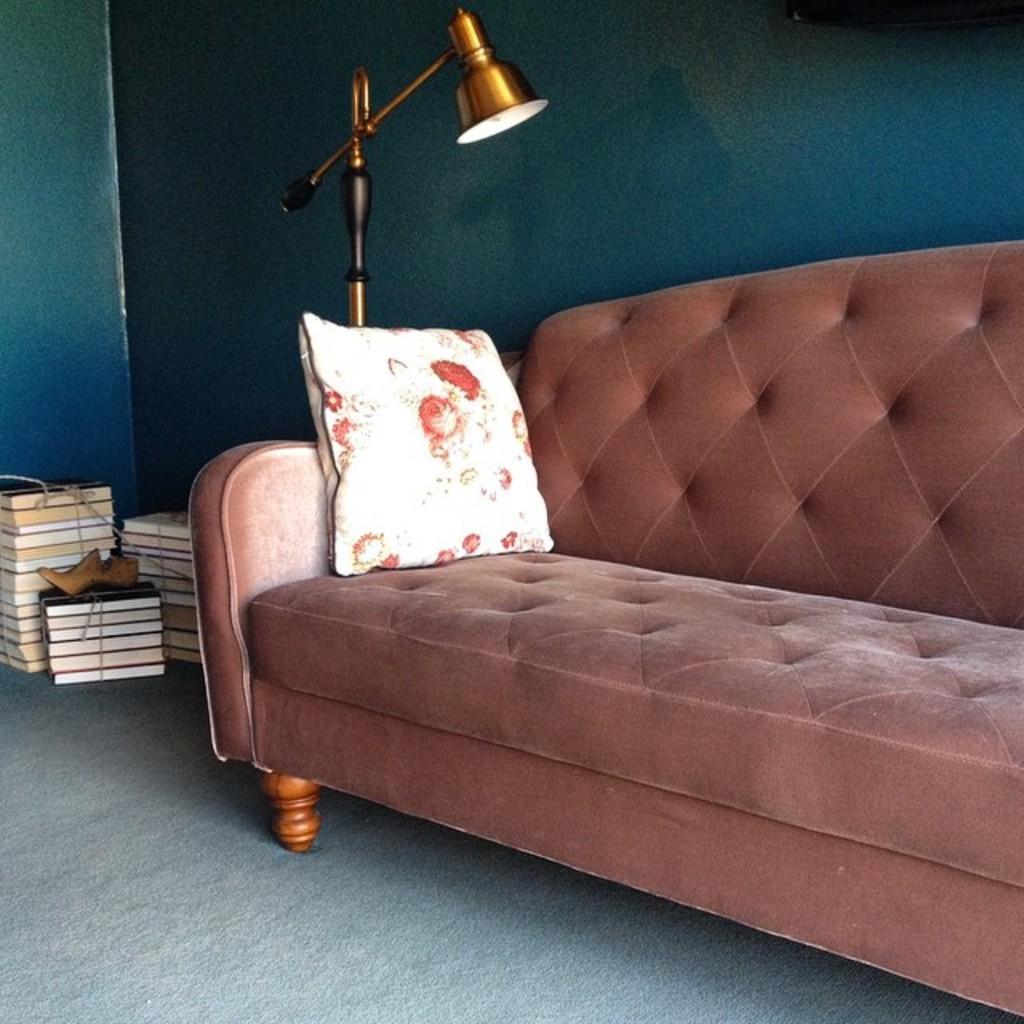What type of furniture is in the image? There is a sofa in the image. What is placed on the sofa? There is a pillow and a lamp on the sofa. What objects can be seen at the bottom of the image? There are books and a shoe at the bottom of the image. What is visible in the background of the image? There is a wall in the background of the image. How does the sofa compare to the pot in the image? There is no pot present in the image, so it cannot be compared to the sofa. What time is it according to the clocks in the image? There are no clocks visible in the image. 